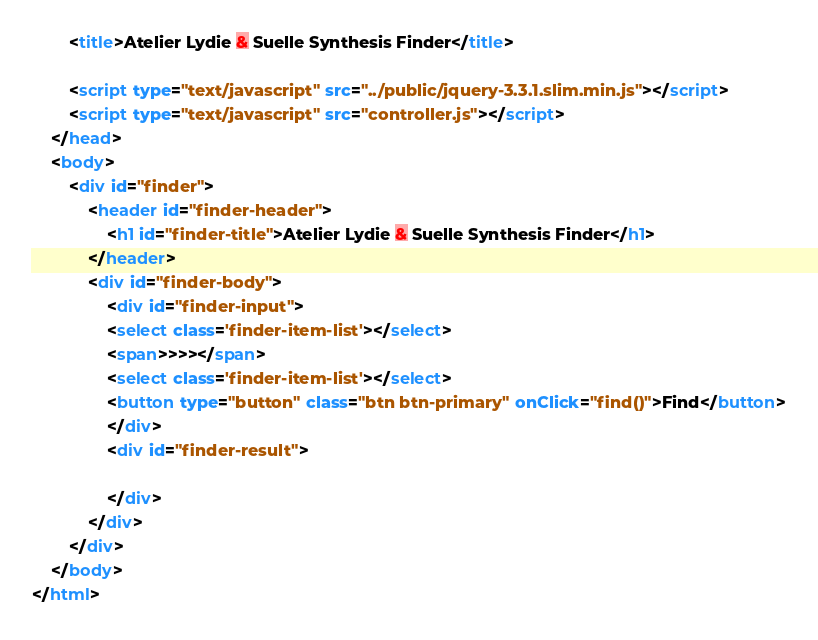Convert code to text. <code><loc_0><loc_0><loc_500><loc_500><_HTML_>        <title>Atelier Lydie & Suelle Synthesis Finder</title>
        
        <script type="text/javascript" src="../public/jquery-3.3.1.slim.min.js"></script>
        <script type="text/javascript" src="controller.js"></script>
    </head>
    <body>
        <div id="finder">
            <header id="finder-header">
                <h1 id="finder-title">Atelier Lydie & Suelle Synthesis Finder</h1>
            </header>
            <div id="finder-body">
                <div id="finder-input">
                <select class='finder-item-list'></select>
                <span>>>></span>
                <select class='finder-item-list'></select>
                <button type="button" class="btn btn-primary" onClick="find()">Find</button>
                </div>
                <div id="finder-result">
                
                </div>
            </div>
        </div>
    </body>
</html></code> 